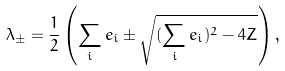Convert formula to latex. <formula><loc_0><loc_0><loc_500><loc_500>\lambda _ { \pm } = \frac { 1 } { 2 } \left ( \sum _ { i } e _ { i } \pm \sqrt { ( \sum _ { i } e _ { i } ) ^ { 2 } - 4 Z } \right ) ,</formula> 